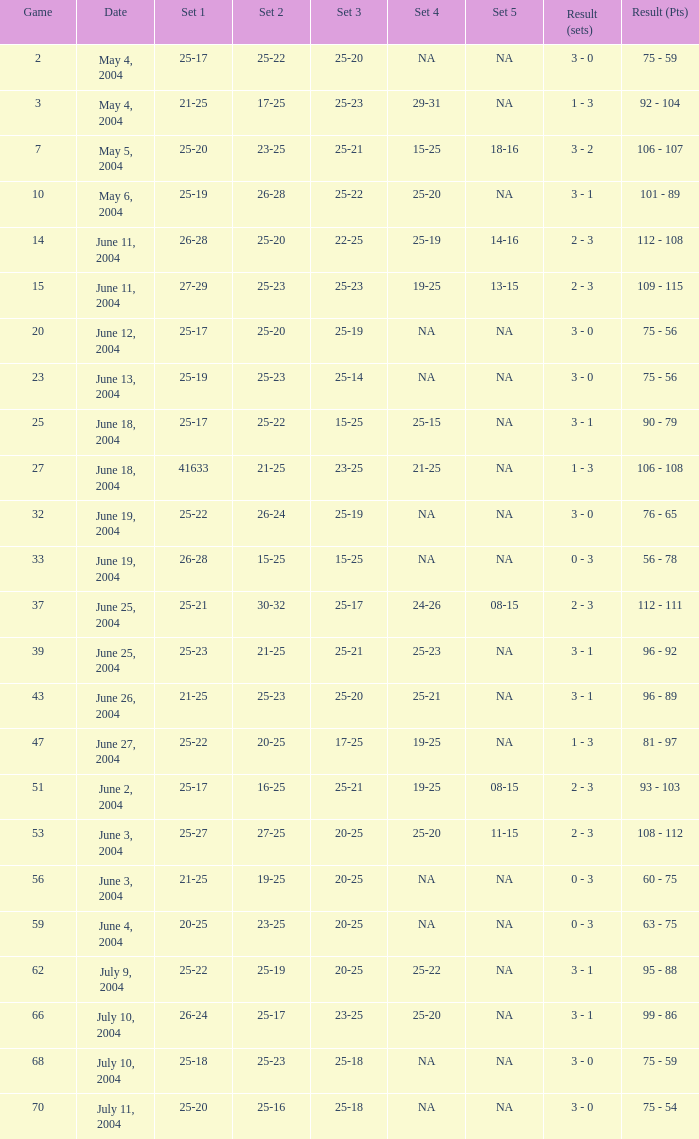What is the set 5 for the game with a set 2 of 21-25 and a set 1 of 41633? NA. 